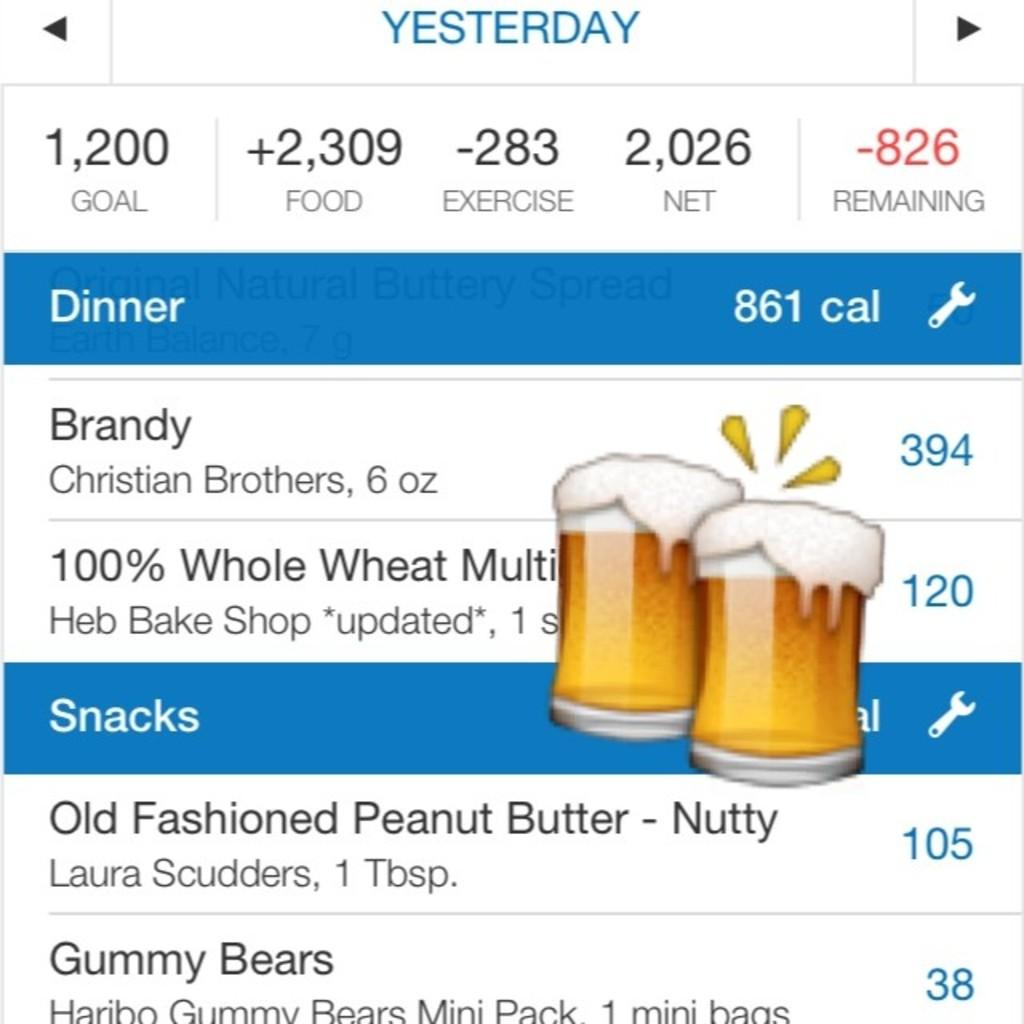<image>
Provide a brief description of the given image. A list of stats and calories for dinner and snacks including brandy and peanut butter. 